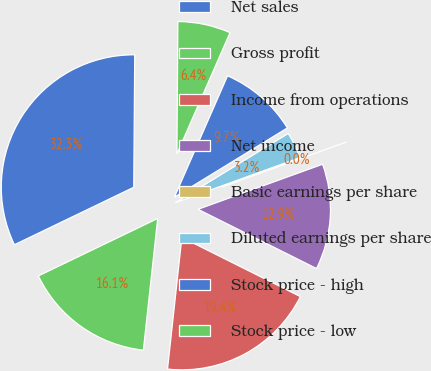Convert chart to OTSL. <chart><loc_0><loc_0><loc_500><loc_500><pie_chart><fcel>Net sales<fcel>Gross profit<fcel>Income from operations<fcel>Net income<fcel>Basic earnings per share<fcel>Diluted earnings per share<fcel>Stock price - high<fcel>Stock price - low<nl><fcel>32.26%<fcel>16.13%<fcel>19.35%<fcel>12.9%<fcel>0.0%<fcel>3.23%<fcel>9.68%<fcel>6.45%<nl></chart> 